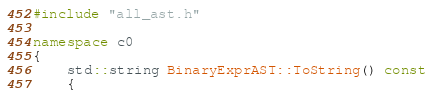<code> <loc_0><loc_0><loc_500><loc_500><_C++_>#include "all_ast.h"

namespace c0
{
    std::string BinaryExprAST::ToString() const
    {</code> 